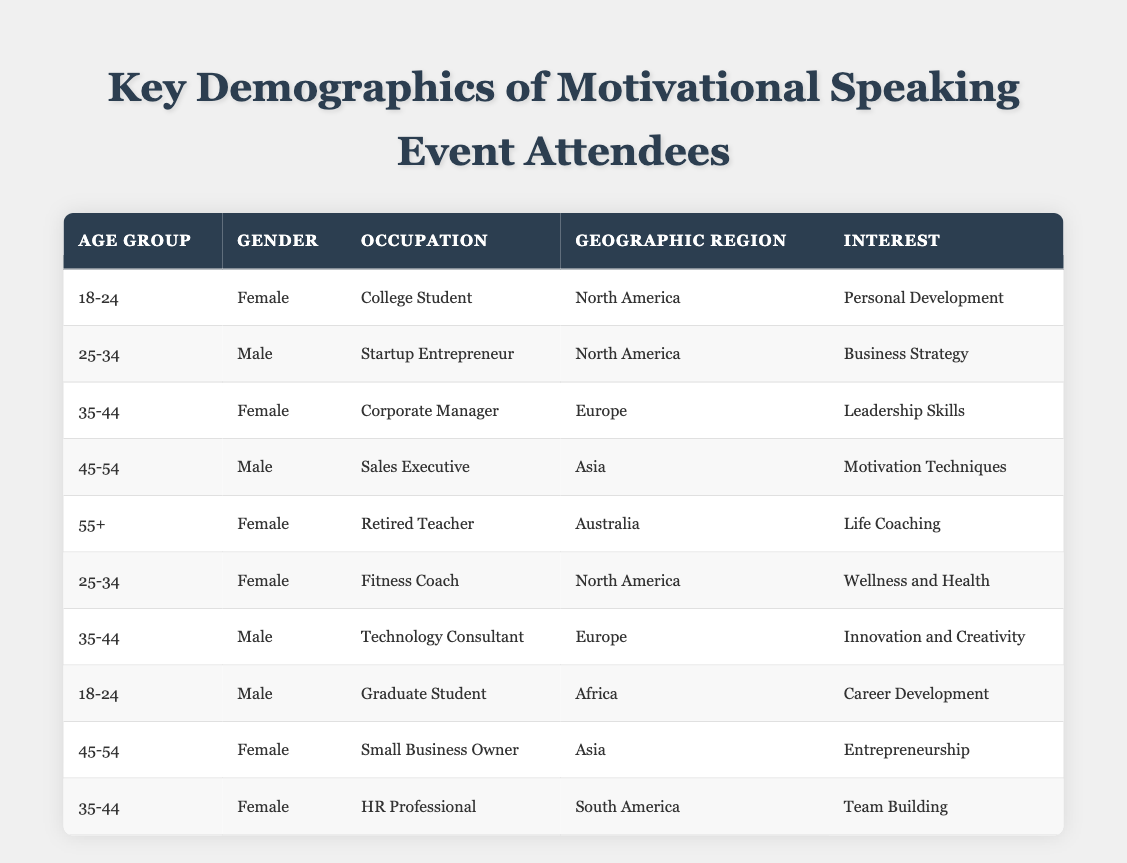What is the most common age group represented at the event? The table lists attendees from various age groups. The age groups provided are: 18-24, 25-34, 35-44, 45-54, and 55+. Counting the occurrences in the table, the age group 35-44 appears three times, while the other age groups appear less frequently.
Answer: 35-44 How many male attendees are there in total? To find the total number of male attendees, we can look at the Gender column and count all entries labeled as Male. There are four entries corresponding to males in the table: two in the age group 25-34, one in 45-54, and one in the 35-44 age group.
Answer: 4 What percentage of attendees are interested in "Personal Development"? Only one attendee in the 18-24 age group has the interest labeled "Personal Development." There are a total of 10 attendees, so the percentage is calculated as (1/10) * 100 = 10%.
Answer: 10% Is there an attendee from Africa, and if so, what is their occupation? Looking through the Geographic Region column, there is one attendee listed from Africa, who is a Graduate Student.
Answer: Yes, Graduate Student Which interest category appears most frequently among the attendees? By scanning the Interest column, the interests listed are Personal Development, Business Strategy, Leadership Skills, Motivation Techniques, Life Coaching, Wellness and Health, Innovation and Creativity, Career Development, Entrepreneurship, and Team Building. The interests Personal Development, Motivation Techniques, and Team Building each appear once, while others also appear once. Hence, there is no single predominant interest.
Answer: All appear equally How many attendees are from Asia, and what roles do they hold? In the table, two individuals are from Asia: a Sales Executive (aged 45-54) and a Small Business Owner (aged 45-54). Therefore, there are two attendees from Asia.
Answer: 2, Sales Executive and Small Business Owner What is the average age of the attendees? Age groups listed are 18-24, 25-34, 35-44, 45-54, and 55+. To find the average, we can assign median ages to these ranges: 21, 29.5, 39.5, 49.5, and 60 respectively. Calculating these values: (21 + 29.5 + 39.5 + 49.5 + 60) = 199.5 and dividing by 5 gives us an average age of 39.9.
Answer: 39.9 Are there more female attendees than male attendees? Counting the Gender column, we find five female attendees and four male attendees. Thus, there are more females present than males.
Answer: Yes What percentage of the attendees are college students? There is one College Student in the 18-24 age group out of 10 total attendees. Thus, the percentage can be calculated as (1/10) * 100 = 10%.
Answer: 10% How many attendees have an interest related to health? The only attendee whose interest relates to health is the Fitness Coach, who is focused on Wellness and Health. There is only one such attendee.
Answer: 1 What is the median age group among attendees? Listing all the age groups in order: 18-24, 18-24, 25-34, 25-34, 35-44, 35-44, 35-44, 45-54, 45-54, 55+, the median would be the middle value. As there are ten groups, the median falls between the 5th and 6th value which are both 35-44, therefore the median age group is 35-44.
Answer: 35-44 